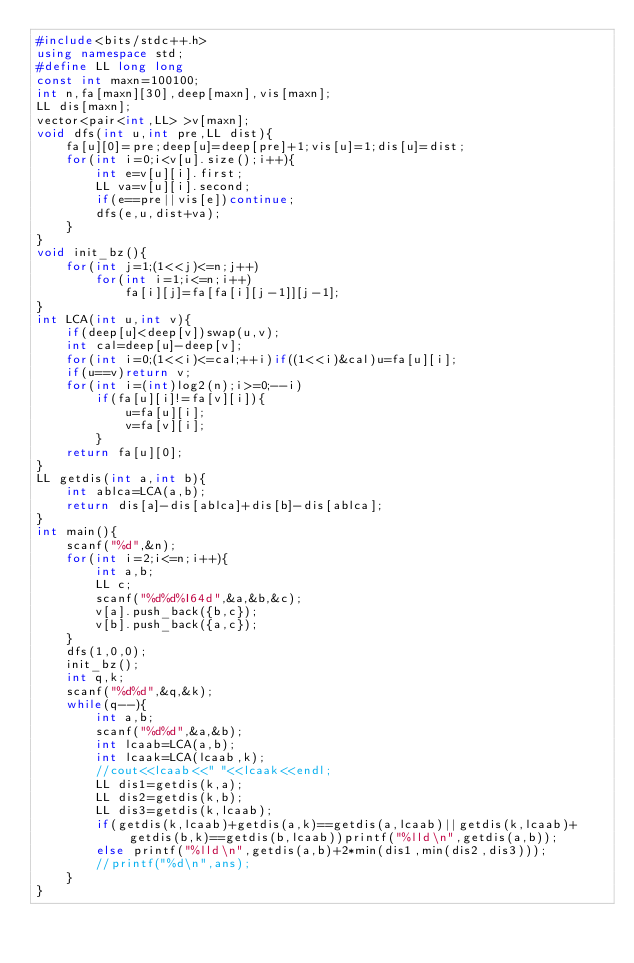Convert code to text. <code><loc_0><loc_0><loc_500><loc_500><_C++_>#include<bits/stdc++.h>
using namespace std;
#define LL long long
const int maxn=100100;
int n,fa[maxn][30],deep[maxn],vis[maxn];
LL dis[maxn];
vector<pair<int,LL> >v[maxn];
void dfs(int u,int pre,LL dist){
	fa[u][0]=pre;deep[u]=deep[pre]+1;vis[u]=1;dis[u]=dist;
	for(int i=0;i<v[u].size();i++){
		int e=v[u][i].first;
		LL va=v[u][i].second;
		if(e==pre||vis[e])continue;
		dfs(e,u,dist+va);
	}
}
void init_bz(){
	for(int j=1;(1<<j)<=n;j++)
		for(int i=1;i<=n;i++)
			fa[i][j]=fa[fa[i][j-1]][j-1];
}
int LCA(int u,int v){
	if(deep[u]<deep[v])swap(u,v);
	int cal=deep[u]-deep[v];
	for(int i=0;(1<<i)<=cal;++i)if((1<<i)&cal)u=fa[u][i];
	if(u==v)return v;
	for(int i=(int)log2(n);i>=0;--i)
		if(fa[u][i]!=fa[v][i]){
			u=fa[u][i];
			v=fa[v][i];
		}
	return fa[u][0];
}
LL getdis(int a,int b){
    int ablca=LCA(a,b);
    return dis[a]-dis[ablca]+dis[b]-dis[ablca];
}
int main(){
	scanf("%d",&n);
	for(int i=2;i<=n;i++){
		int a,b;
		LL c;
		scanf("%d%d%I64d",&a,&b,&c);
		v[a].push_back({b,c});
		v[b].push_back({a,c});
	}
	dfs(1,0,0);
	init_bz();
	int q,k;
	scanf("%d%d",&q,&k);
	while(q--){
		int a,b;
        scanf("%d%d",&a,&b);
        int lcaab=LCA(a,b);
        int lcaak=LCA(lcaab,k);
        //cout<<lcaab<<" "<<lcaak<<endl;
        LL dis1=getdis(k,a);
        LL dis2=getdis(k,b);
        LL dis3=getdis(k,lcaab);
        if(getdis(k,lcaab)+getdis(a,k)==getdis(a,lcaab)||getdis(k,lcaab)+getdis(b,k)==getdis(b,lcaab))printf("%lld\n",getdis(a,b));
        else printf("%lld\n",getdis(a,b)+2*min(dis1,min(dis2,dis3)));
		//printf("%d\n",ans);
	}
}
</code> 